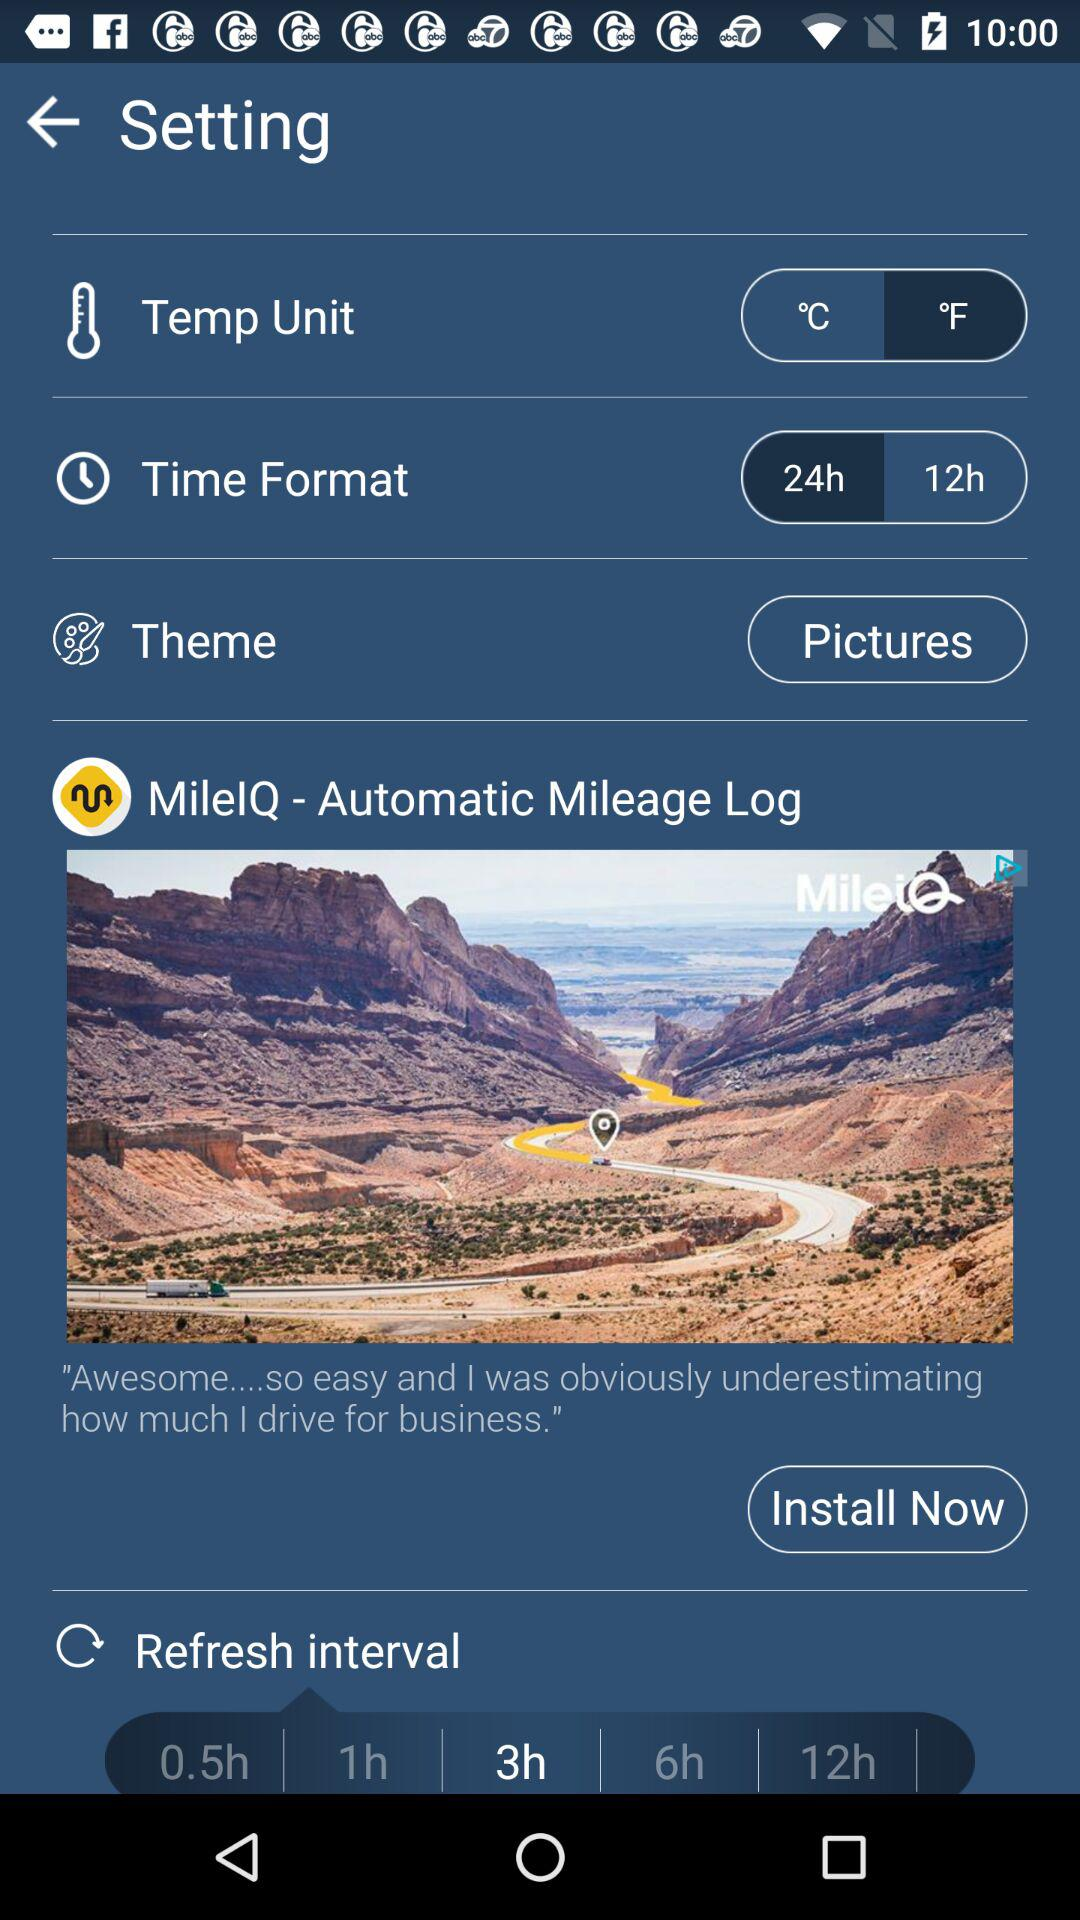What is the chosen temperature unit? The chosen temperature unit is °F. 